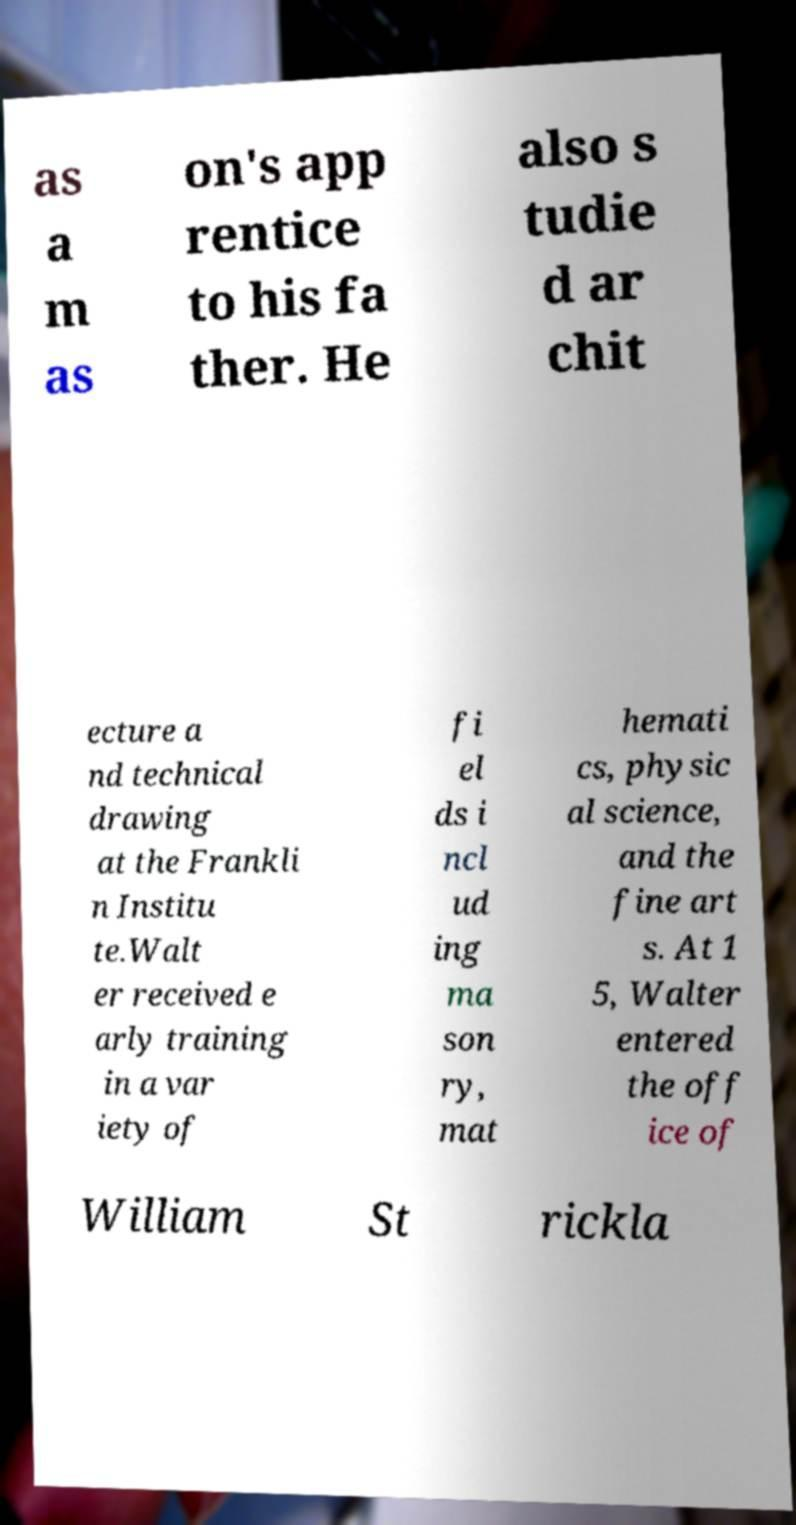Please identify and transcribe the text found in this image. as a m as on's app rentice to his fa ther. He also s tudie d ar chit ecture a nd technical drawing at the Frankli n Institu te.Walt er received e arly training in a var iety of fi el ds i ncl ud ing ma son ry, mat hemati cs, physic al science, and the fine art s. At 1 5, Walter entered the off ice of William St rickla 